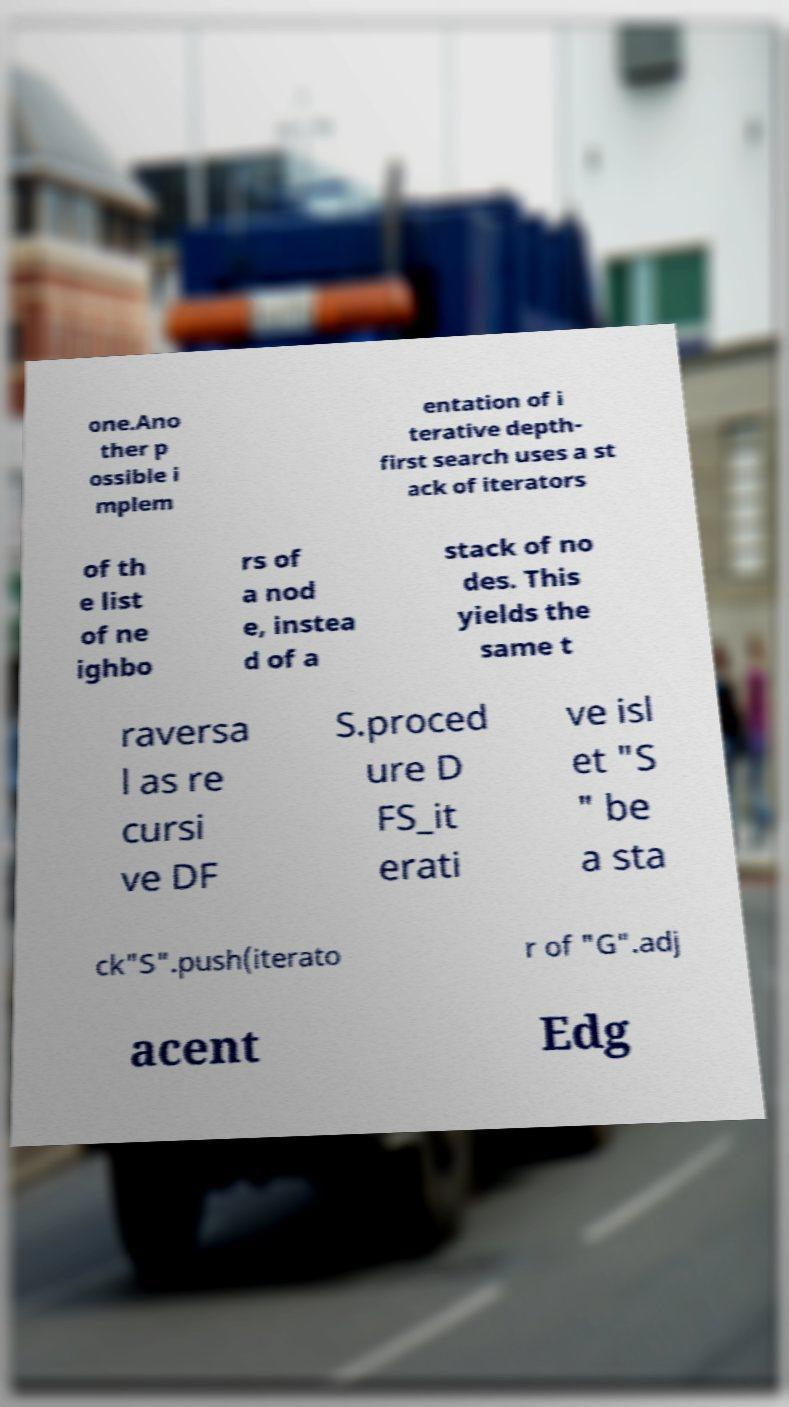Could you extract and type out the text from this image? one.Ano ther p ossible i mplem entation of i terative depth- first search uses a st ack of iterators of th e list of ne ighbo rs of a nod e, instea d of a stack of no des. This yields the same t raversa l as re cursi ve DF S.proced ure D FS_it erati ve isl et "S " be a sta ck"S".push(iterato r of "G".adj acent Edg 